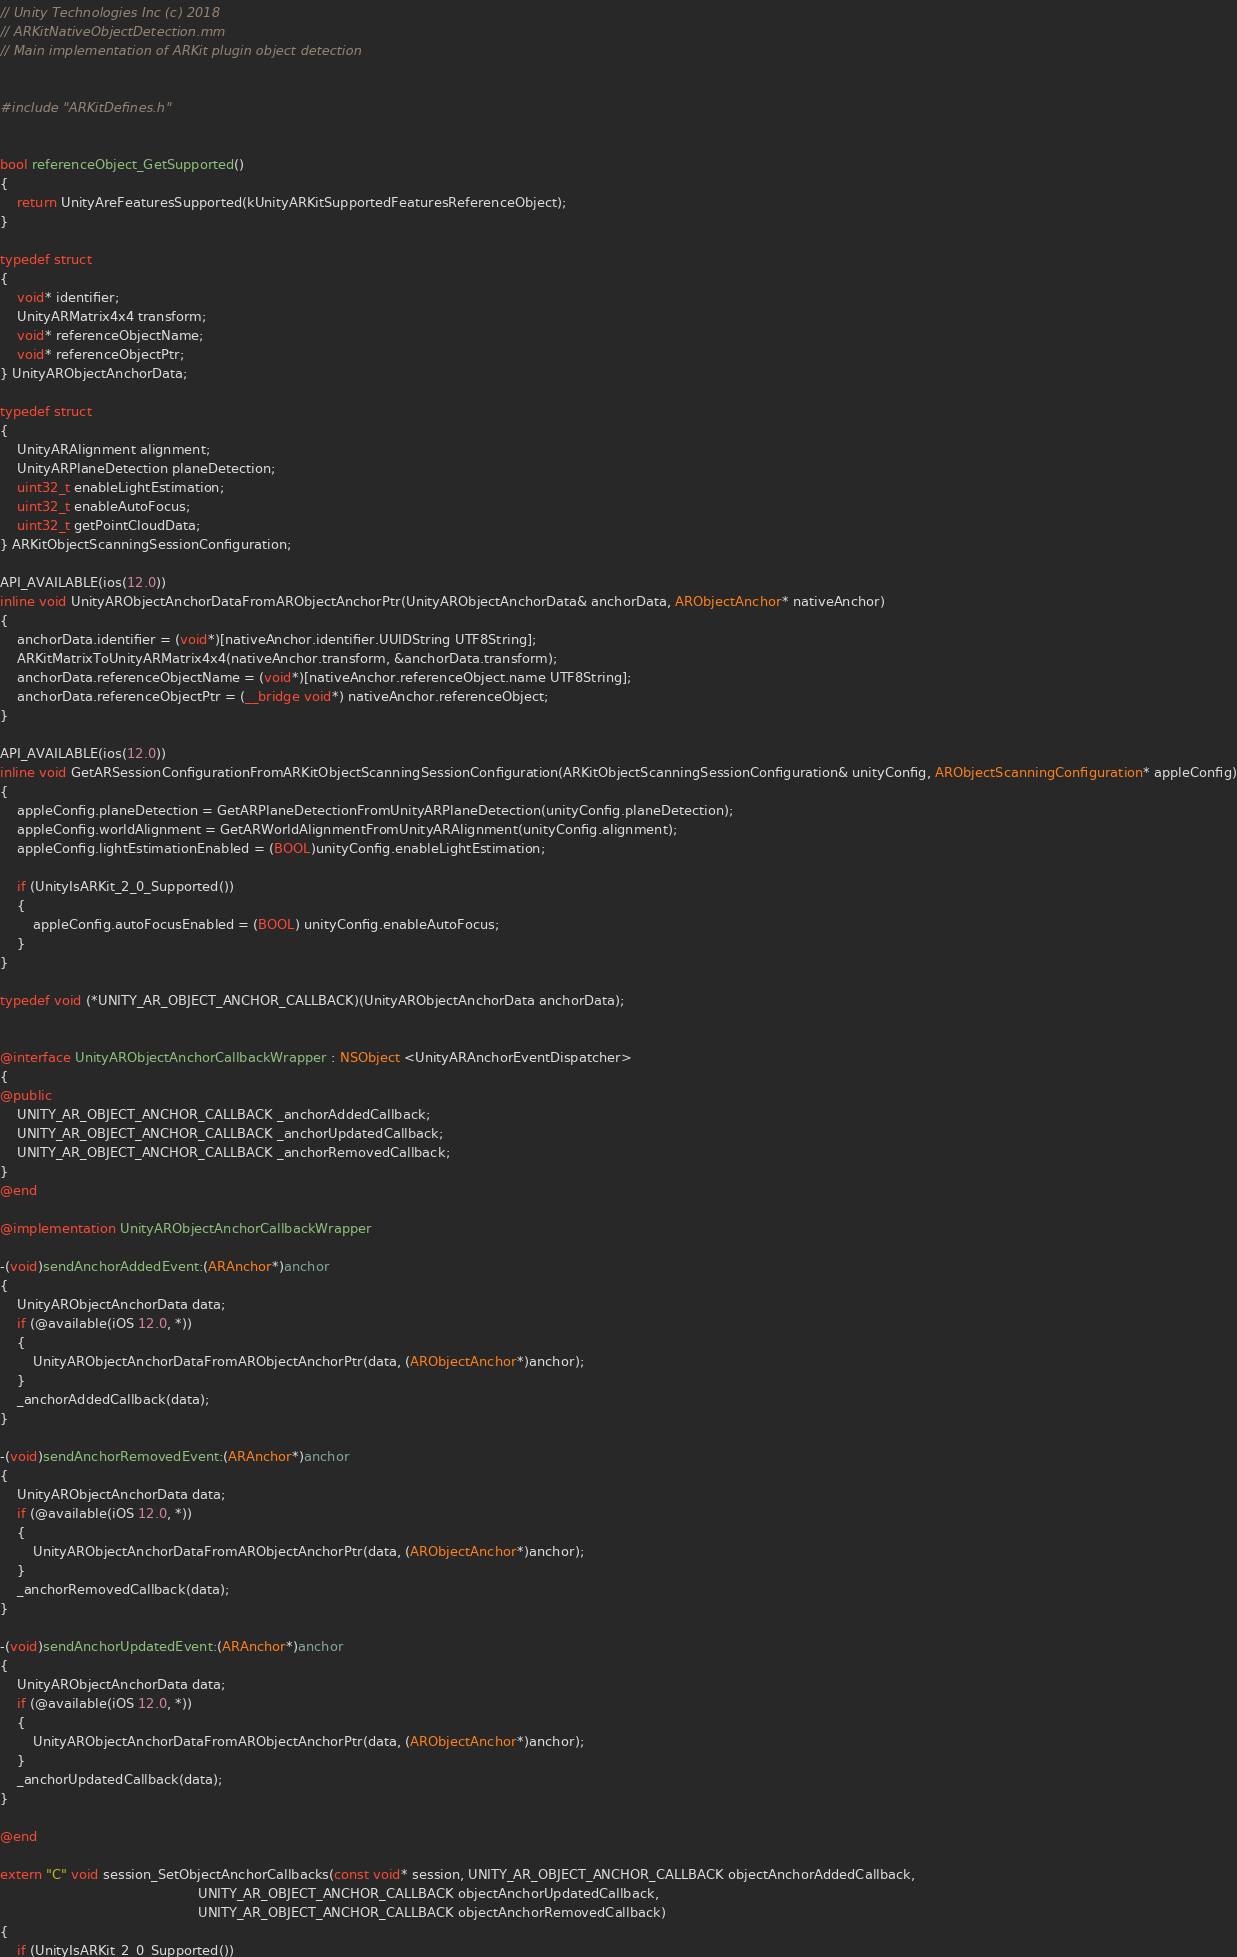Convert code to text. <code><loc_0><loc_0><loc_500><loc_500><_ObjectiveC_>// Unity Technologies Inc (c) 2018
// ARKitNativeObjectDetection.mm
// Main implementation of ARKit plugin object detection


#include "ARKitDefines.h"


bool referenceObject_GetSupported()
{
    return UnityAreFeaturesSupported(kUnityARKitSupportedFeaturesReferenceObject);
}

typedef struct
{
    void* identifier;
    UnityARMatrix4x4 transform;
    void* referenceObjectName;
    void* referenceObjectPtr;
} UnityARObjectAnchorData;

typedef struct
{
    UnityARAlignment alignment;
    UnityARPlaneDetection planeDetection;
    uint32_t enableLightEstimation;
    uint32_t enableAutoFocus;
    uint32_t getPointCloudData;
} ARKitObjectScanningSessionConfiguration;

API_AVAILABLE(ios(12.0))
inline void UnityARObjectAnchorDataFromARObjectAnchorPtr(UnityARObjectAnchorData& anchorData, ARObjectAnchor* nativeAnchor)
{
    anchorData.identifier = (void*)[nativeAnchor.identifier.UUIDString UTF8String];
    ARKitMatrixToUnityARMatrix4x4(nativeAnchor.transform, &anchorData.transform);
    anchorData.referenceObjectName = (void*)[nativeAnchor.referenceObject.name UTF8String];
    anchorData.referenceObjectPtr = (__bridge void*) nativeAnchor.referenceObject;
}

API_AVAILABLE(ios(12.0))
inline void GetARSessionConfigurationFromARKitObjectScanningSessionConfiguration(ARKitObjectScanningSessionConfiguration& unityConfig, ARObjectScanningConfiguration* appleConfig)
{
    appleConfig.planeDetection = GetARPlaneDetectionFromUnityARPlaneDetection(unityConfig.planeDetection);
    appleConfig.worldAlignment = GetARWorldAlignmentFromUnityARAlignment(unityConfig.alignment);
    appleConfig.lightEstimationEnabled = (BOOL)unityConfig.enableLightEstimation;
    
    if (UnityIsARKit_2_0_Supported())
    {
        appleConfig.autoFocusEnabled = (BOOL) unityConfig.enableAutoFocus;
    }
}

typedef void (*UNITY_AR_OBJECT_ANCHOR_CALLBACK)(UnityARObjectAnchorData anchorData);


@interface UnityARObjectAnchorCallbackWrapper : NSObject <UnityARAnchorEventDispatcher>
{
@public
    UNITY_AR_OBJECT_ANCHOR_CALLBACK _anchorAddedCallback;
    UNITY_AR_OBJECT_ANCHOR_CALLBACK _anchorUpdatedCallback;
    UNITY_AR_OBJECT_ANCHOR_CALLBACK _anchorRemovedCallback;
}
@end

@implementation UnityARObjectAnchorCallbackWrapper

-(void)sendAnchorAddedEvent:(ARAnchor*)anchor
{
    UnityARObjectAnchorData data;
    if (@available(iOS 12.0, *))
    {
        UnityARObjectAnchorDataFromARObjectAnchorPtr(data, (ARObjectAnchor*)anchor);
    }
    _anchorAddedCallback(data);
}

-(void)sendAnchorRemovedEvent:(ARAnchor*)anchor
{
    UnityARObjectAnchorData data;
    if (@available(iOS 12.0, *))
    {
        UnityARObjectAnchorDataFromARObjectAnchorPtr(data, (ARObjectAnchor*)anchor);
    }
    _anchorRemovedCallback(data);
}

-(void)sendAnchorUpdatedEvent:(ARAnchor*)anchor
{
    UnityARObjectAnchorData data;
    if (@available(iOS 12.0, *))
    {
        UnityARObjectAnchorDataFromARObjectAnchorPtr(data, (ARObjectAnchor*)anchor);
    }
    _anchorUpdatedCallback(data);
}

@end

extern "C" void session_SetObjectAnchorCallbacks(const void* session, UNITY_AR_OBJECT_ANCHOR_CALLBACK objectAnchorAddedCallback,
                                                UNITY_AR_OBJECT_ANCHOR_CALLBACK objectAnchorUpdatedCallback,
                                                UNITY_AR_OBJECT_ANCHOR_CALLBACK objectAnchorRemovedCallback)
{
    if (UnityIsARKit_2_0_Supported())</code> 